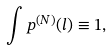Convert formula to latex. <formula><loc_0><loc_0><loc_500><loc_500>\int p ^ { ( N ) } ( l ) \equiv 1 ,</formula> 